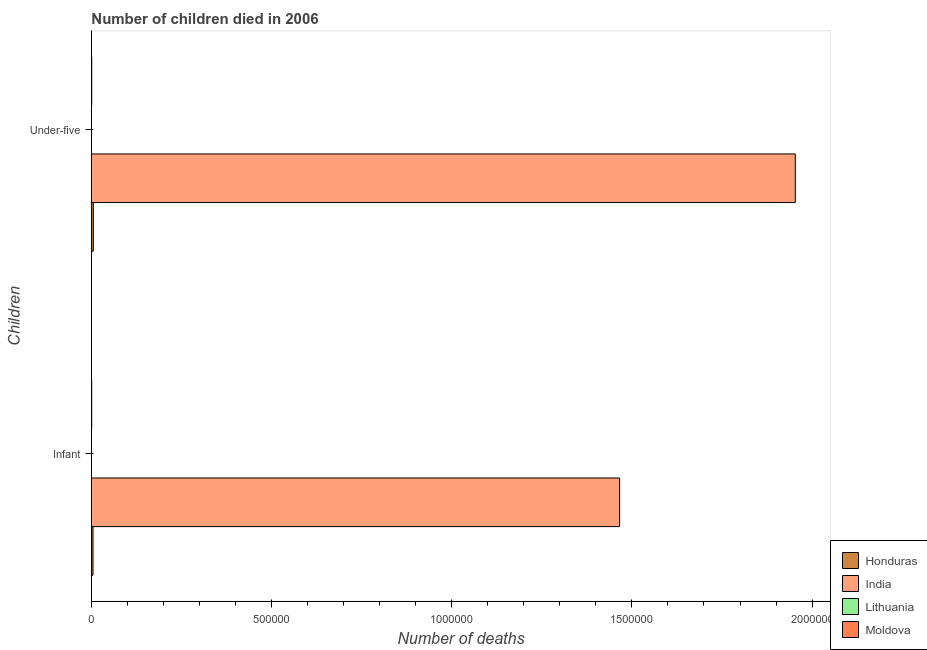How many different coloured bars are there?
Make the answer very short. 4. How many groups of bars are there?
Ensure brevity in your answer.  2. How many bars are there on the 2nd tick from the top?
Provide a succinct answer. 4. What is the label of the 1st group of bars from the top?
Ensure brevity in your answer.  Under-five. What is the number of under-five deaths in Honduras?
Give a very brief answer. 5268. Across all countries, what is the maximum number of infant deaths?
Offer a very short reply. 1.47e+06. Across all countries, what is the minimum number of under-five deaths?
Ensure brevity in your answer.  287. In which country was the number of infant deaths maximum?
Give a very brief answer. India. In which country was the number of under-five deaths minimum?
Keep it short and to the point. Lithuania. What is the total number of infant deaths in the graph?
Offer a terse response. 1.47e+06. What is the difference between the number of infant deaths in India and that in Honduras?
Give a very brief answer. 1.46e+06. What is the difference between the number of under-five deaths in Honduras and the number of infant deaths in Moldova?
Provide a short and direct response. 4577. What is the average number of under-five deaths per country?
Offer a very short reply. 4.90e+05. What is the difference between the number of under-five deaths and number of infant deaths in Honduras?
Your response must be concise. 882. In how many countries, is the number of infant deaths greater than 1000000 ?
Make the answer very short. 1. What is the ratio of the number of infant deaths in Lithuania to that in India?
Make the answer very short. 0. Is the number of under-five deaths in Honduras less than that in India?
Offer a terse response. Yes. What does the 1st bar from the bottom in Infant represents?
Offer a very short reply. Honduras. Are all the bars in the graph horizontal?
Your answer should be compact. Yes. How many countries are there in the graph?
Your response must be concise. 4. What is the difference between two consecutive major ticks on the X-axis?
Provide a succinct answer. 5.00e+05. Are the values on the major ticks of X-axis written in scientific E-notation?
Your answer should be compact. No. Does the graph contain grids?
Make the answer very short. No. How many legend labels are there?
Ensure brevity in your answer.  4. How are the legend labels stacked?
Your response must be concise. Vertical. What is the title of the graph?
Keep it short and to the point. Number of children died in 2006. Does "Finland" appear as one of the legend labels in the graph?
Your response must be concise. No. What is the label or title of the X-axis?
Your response must be concise. Number of deaths. What is the label or title of the Y-axis?
Offer a very short reply. Children. What is the Number of deaths of Honduras in Infant?
Make the answer very short. 4386. What is the Number of deaths of India in Infant?
Keep it short and to the point. 1.47e+06. What is the Number of deaths in Lithuania in Infant?
Your answer should be very brief. 235. What is the Number of deaths in Moldova in Infant?
Provide a succinct answer. 691. What is the Number of deaths in Honduras in Under-five?
Keep it short and to the point. 5268. What is the Number of deaths of India in Under-five?
Provide a short and direct response. 1.95e+06. What is the Number of deaths in Lithuania in Under-five?
Your answer should be very brief. 287. What is the Number of deaths in Moldova in Under-five?
Give a very brief answer. 804. Across all Children, what is the maximum Number of deaths of Honduras?
Offer a terse response. 5268. Across all Children, what is the maximum Number of deaths in India?
Your response must be concise. 1.95e+06. Across all Children, what is the maximum Number of deaths in Lithuania?
Make the answer very short. 287. Across all Children, what is the maximum Number of deaths in Moldova?
Ensure brevity in your answer.  804. Across all Children, what is the minimum Number of deaths in Honduras?
Give a very brief answer. 4386. Across all Children, what is the minimum Number of deaths of India?
Your response must be concise. 1.47e+06. Across all Children, what is the minimum Number of deaths of Lithuania?
Keep it short and to the point. 235. Across all Children, what is the minimum Number of deaths of Moldova?
Make the answer very short. 691. What is the total Number of deaths in Honduras in the graph?
Your answer should be very brief. 9654. What is the total Number of deaths in India in the graph?
Give a very brief answer. 3.42e+06. What is the total Number of deaths in Lithuania in the graph?
Ensure brevity in your answer.  522. What is the total Number of deaths of Moldova in the graph?
Ensure brevity in your answer.  1495. What is the difference between the Number of deaths of Honduras in Infant and that in Under-five?
Provide a short and direct response. -882. What is the difference between the Number of deaths of India in Infant and that in Under-five?
Provide a short and direct response. -4.88e+05. What is the difference between the Number of deaths in Lithuania in Infant and that in Under-five?
Keep it short and to the point. -52. What is the difference between the Number of deaths of Moldova in Infant and that in Under-five?
Make the answer very short. -113. What is the difference between the Number of deaths of Honduras in Infant and the Number of deaths of India in Under-five?
Your answer should be very brief. -1.95e+06. What is the difference between the Number of deaths in Honduras in Infant and the Number of deaths in Lithuania in Under-five?
Your answer should be compact. 4099. What is the difference between the Number of deaths in Honduras in Infant and the Number of deaths in Moldova in Under-five?
Keep it short and to the point. 3582. What is the difference between the Number of deaths of India in Infant and the Number of deaths of Lithuania in Under-five?
Provide a short and direct response. 1.47e+06. What is the difference between the Number of deaths in India in Infant and the Number of deaths in Moldova in Under-five?
Your response must be concise. 1.47e+06. What is the difference between the Number of deaths in Lithuania in Infant and the Number of deaths in Moldova in Under-five?
Your response must be concise. -569. What is the average Number of deaths of Honduras per Children?
Make the answer very short. 4827. What is the average Number of deaths of India per Children?
Your answer should be very brief. 1.71e+06. What is the average Number of deaths in Lithuania per Children?
Your answer should be compact. 261. What is the average Number of deaths of Moldova per Children?
Offer a terse response. 747.5. What is the difference between the Number of deaths of Honduras and Number of deaths of India in Infant?
Give a very brief answer. -1.46e+06. What is the difference between the Number of deaths of Honduras and Number of deaths of Lithuania in Infant?
Offer a terse response. 4151. What is the difference between the Number of deaths of Honduras and Number of deaths of Moldova in Infant?
Offer a very short reply. 3695. What is the difference between the Number of deaths in India and Number of deaths in Lithuania in Infant?
Your response must be concise. 1.47e+06. What is the difference between the Number of deaths in India and Number of deaths in Moldova in Infant?
Your answer should be very brief. 1.47e+06. What is the difference between the Number of deaths of Lithuania and Number of deaths of Moldova in Infant?
Offer a terse response. -456. What is the difference between the Number of deaths in Honduras and Number of deaths in India in Under-five?
Your answer should be very brief. -1.95e+06. What is the difference between the Number of deaths in Honduras and Number of deaths in Lithuania in Under-five?
Give a very brief answer. 4981. What is the difference between the Number of deaths in Honduras and Number of deaths in Moldova in Under-five?
Provide a short and direct response. 4464. What is the difference between the Number of deaths in India and Number of deaths in Lithuania in Under-five?
Give a very brief answer. 1.95e+06. What is the difference between the Number of deaths in India and Number of deaths in Moldova in Under-five?
Provide a succinct answer. 1.95e+06. What is the difference between the Number of deaths in Lithuania and Number of deaths in Moldova in Under-five?
Keep it short and to the point. -517. What is the ratio of the Number of deaths of Honduras in Infant to that in Under-five?
Ensure brevity in your answer.  0.83. What is the ratio of the Number of deaths in India in Infant to that in Under-five?
Give a very brief answer. 0.75. What is the ratio of the Number of deaths in Lithuania in Infant to that in Under-five?
Make the answer very short. 0.82. What is the ratio of the Number of deaths of Moldova in Infant to that in Under-five?
Your answer should be very brief. 0.86. What is the difference between the highest and the second highest Number of deaths of Honduras?
Your answer should be very brief. 882. What is the difference between the highest and the second highest Number of deaths of India?
Provide a short and direct response. 4.88e+05. What is the difference between the highest and the second highest Number of deaths in Lithuania?
Give a very brief answer. 52. What is the difference between the highest and the second highest Number of deaths in Moldova?
Keep it short and to the point. 113. What is the difference between the highest and the lowest Number of deaths in Honduras?
Give a very brief answer. 882. What is the difference between the highest and the lowest Number of deaths of India?
Offer a terse response. 4.88e+05. What is the difference between the highest and the lowest Number of deaths of Lithuania?
Give a very brief answer. 52. What is the difference between the highest and the lowest Number of deaths of Moldova?
Keep it short and to the point. 113. 